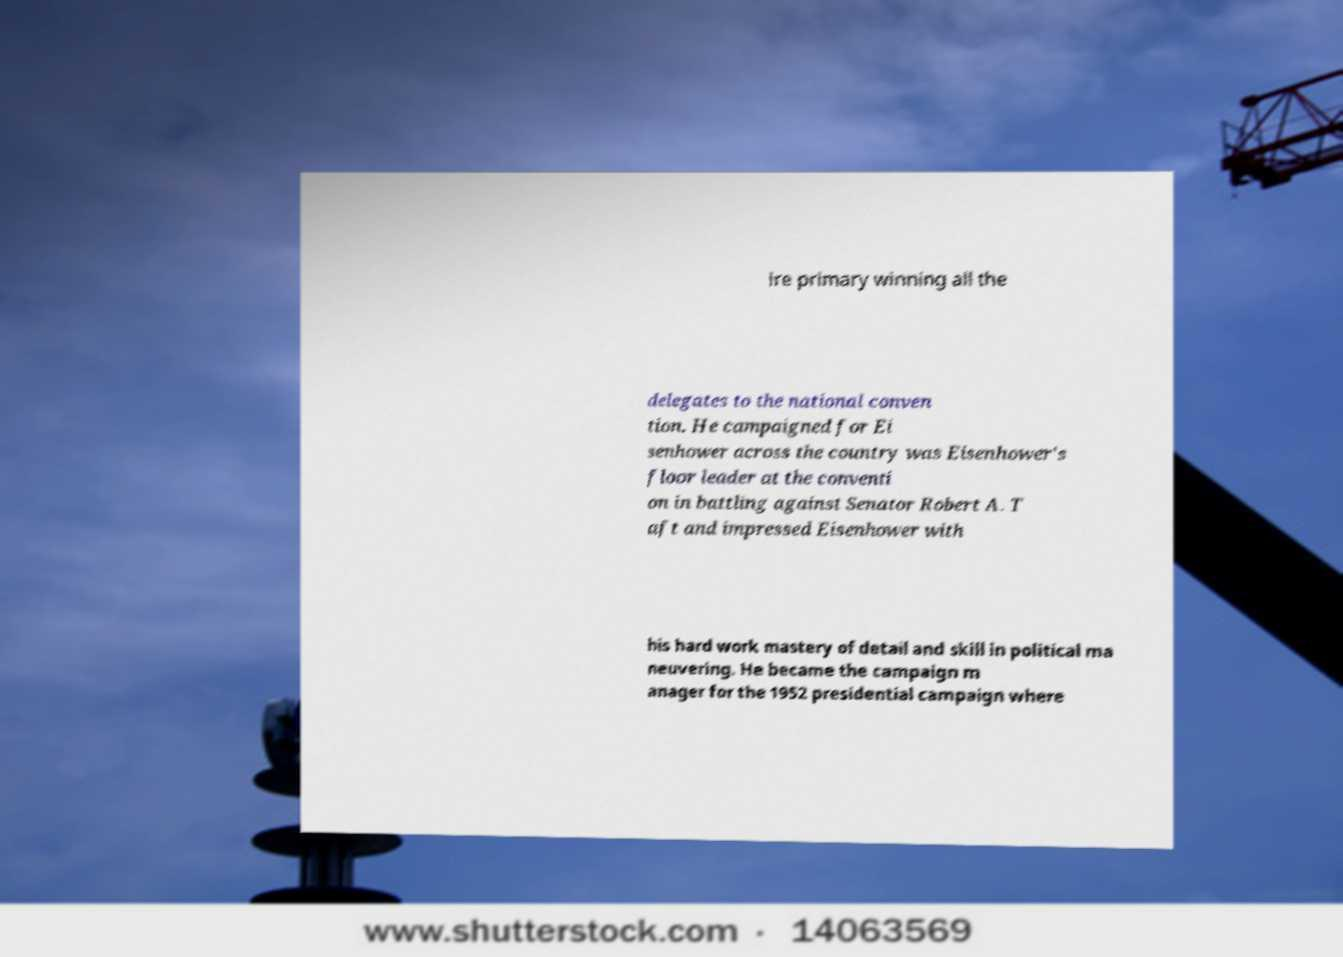Can you read and provide the text displayed in the image?This photo seems to have some interesting text. Can you extract and type it out for me? ire primary winning all the delegates to the national conven tion. He campaigned for Ei senhower across the country was Eisenhower's floor leader at the conventi on in battling against Senator Robert A. T aft and impressed Eisenhower with his hard work mastery of detail and skill in political ma neuvering. He became the campaign m anager for the 1952 presidential campaign where 